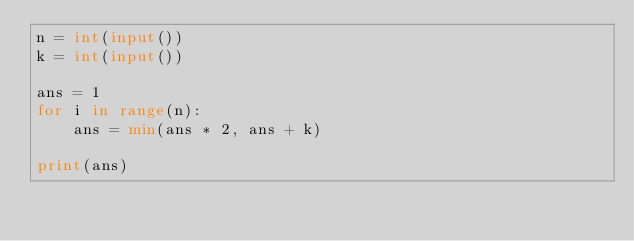<code> <loc_0><loc_0><loc_500><loc_500><_Python_>n = int(input())
k = int(input())

ans = 1
for i in range(n):
    ans = min(ans * 2, ans + k)

print(ans)</code> 